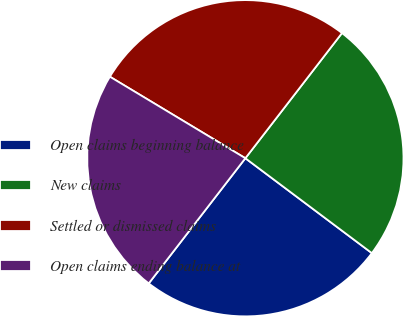<chart> <loc_0><loc_0><loc_500><loc_500><pie_chart><fcel>Open claims beginning balance<fcel>New claims<fcel>Settled or dismissed claims<fcel>Open claims ending balance at<nl><fcel>25.22%<fcel>24.78%<fcel>26.84%<fcel>23.16%<nl></chart> 